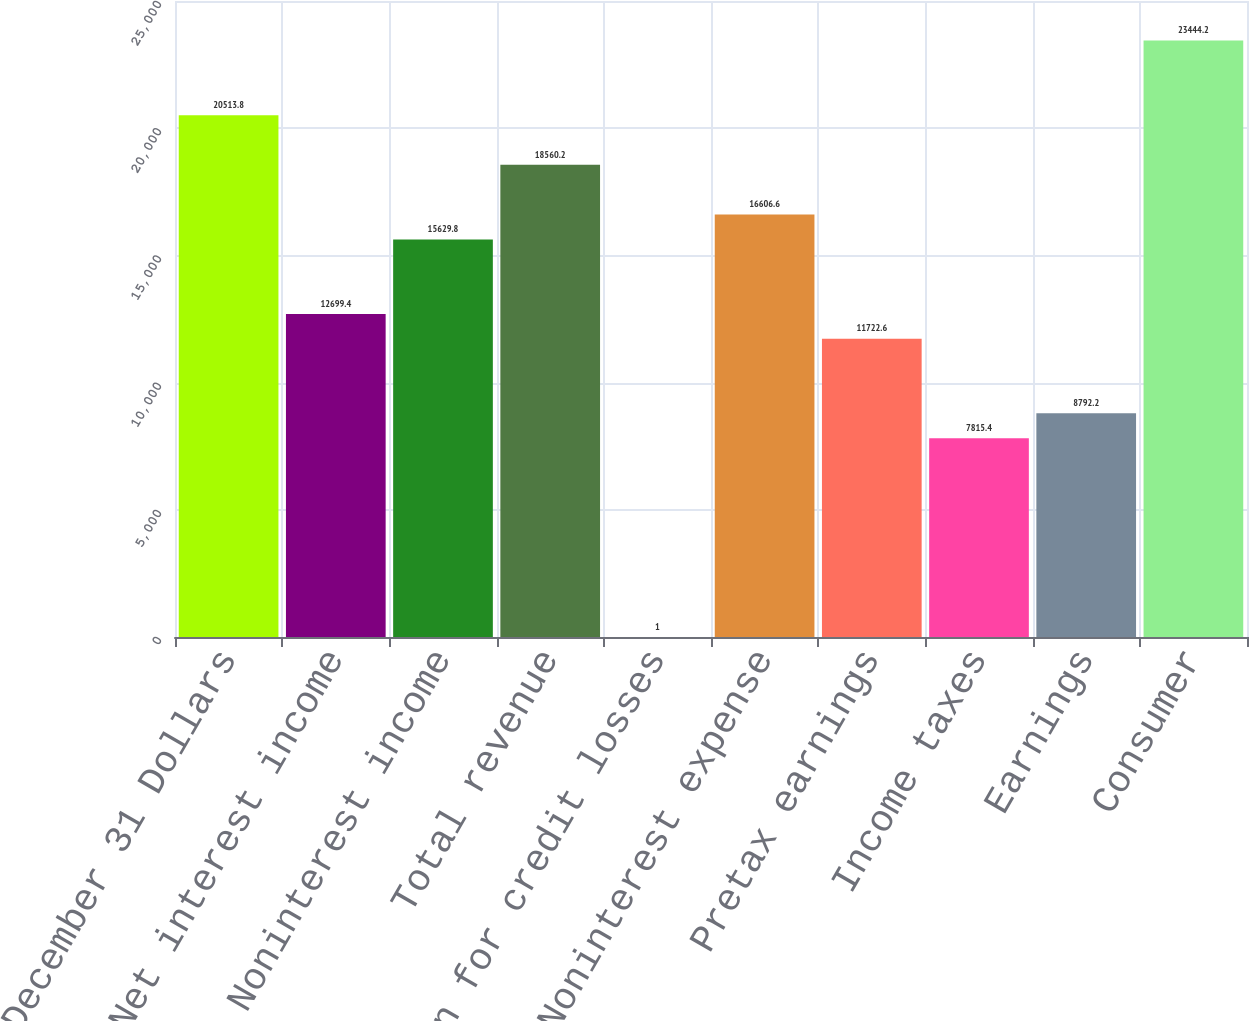Convert chart. <chart><loc_0><loc_0><loc_500><loc_500><bar_chart><fcel>Year ended December 31 Dollars<fcel>Net interest income<fcel>Noninterest income<fcel>Total revenue<fcel>Provision for credit losses<fcel>Noninterest expense<fcel>Pretax earnings<fcel>Income taxes<fcel>Earnings<fcel>Consumer<nl><fcel>20513.8<fcel>12699.4<fcel>15629.8<fcel>18560.2<fcel>1<fcel>16606.6<fcel>11722.6<fcel>7815.4<fcel>8792.2<fcel>23444.2<nl></chart> 